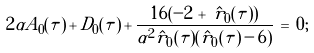Convert formula to latex. <formula><loc_0><loc_0><loc_500><loc_500>2 \alpha A _ { 0 } ( \tau ) \, + \, D _ { 0 } ( \tau ) \, + \, \frac { 1 6 ( - 2 \, + \, \hat { r } _ { 0 } ( \tau ) ) } { \alpha ^ { 2 } \hat { r } _ { 0 } ( \tau ) ( \hat { r } _ { 0 } ( \tau ) \, - \, 6 ) } \, = \, 0 ;</formula> 